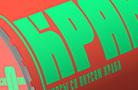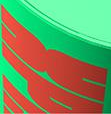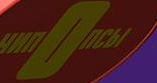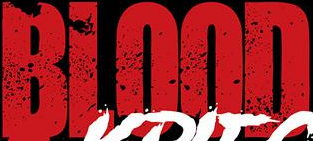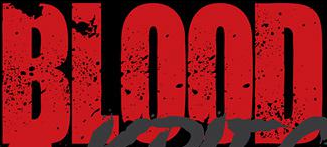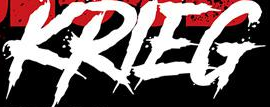What words are shown in these images in order, separated by a semicolon? KPA; dk; nOnCbI; BLOOD; BLOOD; KRIEG 